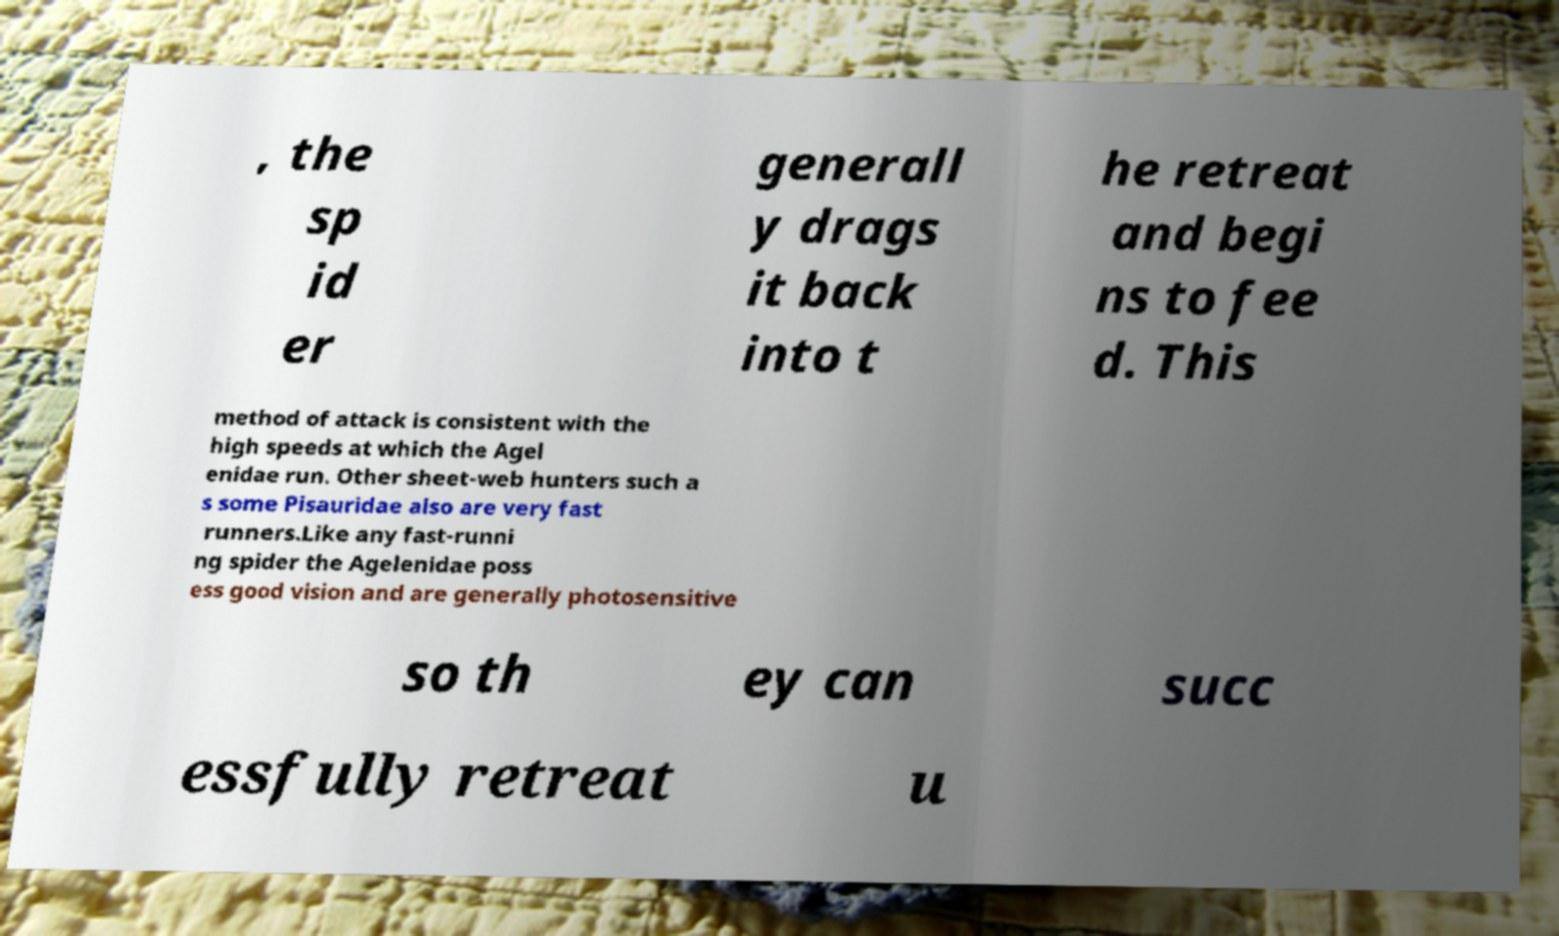Can you accurately transcribe the text from the provided image for me? , the sp id er generall y drags it back into t he retreat and begi ns to fee d. This method of attack is consistent with the high speeds at which the Agel enidae run. Other sheet-web hunters such a s some Pisauridae also are very fast runners.Like any fast-runni ng spider the Agelenidae poss ess good vision and are generally photosensitive so th ey can succ essfully retreat u 